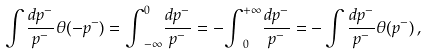<formula> <loc_0><loc_0><loc_500><loc_500>\int \frac { d p ^ { - } } { p ^ { - } } \theta ( - p ^ { - } ) = { \int } _ { - \infty } ^ { 0 } \frac { d p ^ { - } } { p ^ { - } } = - { \int } _ { 0 } ^ { + \infty } \frac { d p ^ { - } } { p ^ { - } } = - \int \frac { d p ^ { - } } { p ^ { - } } \theta ( p ^ { - } ) \, ,</formula> 